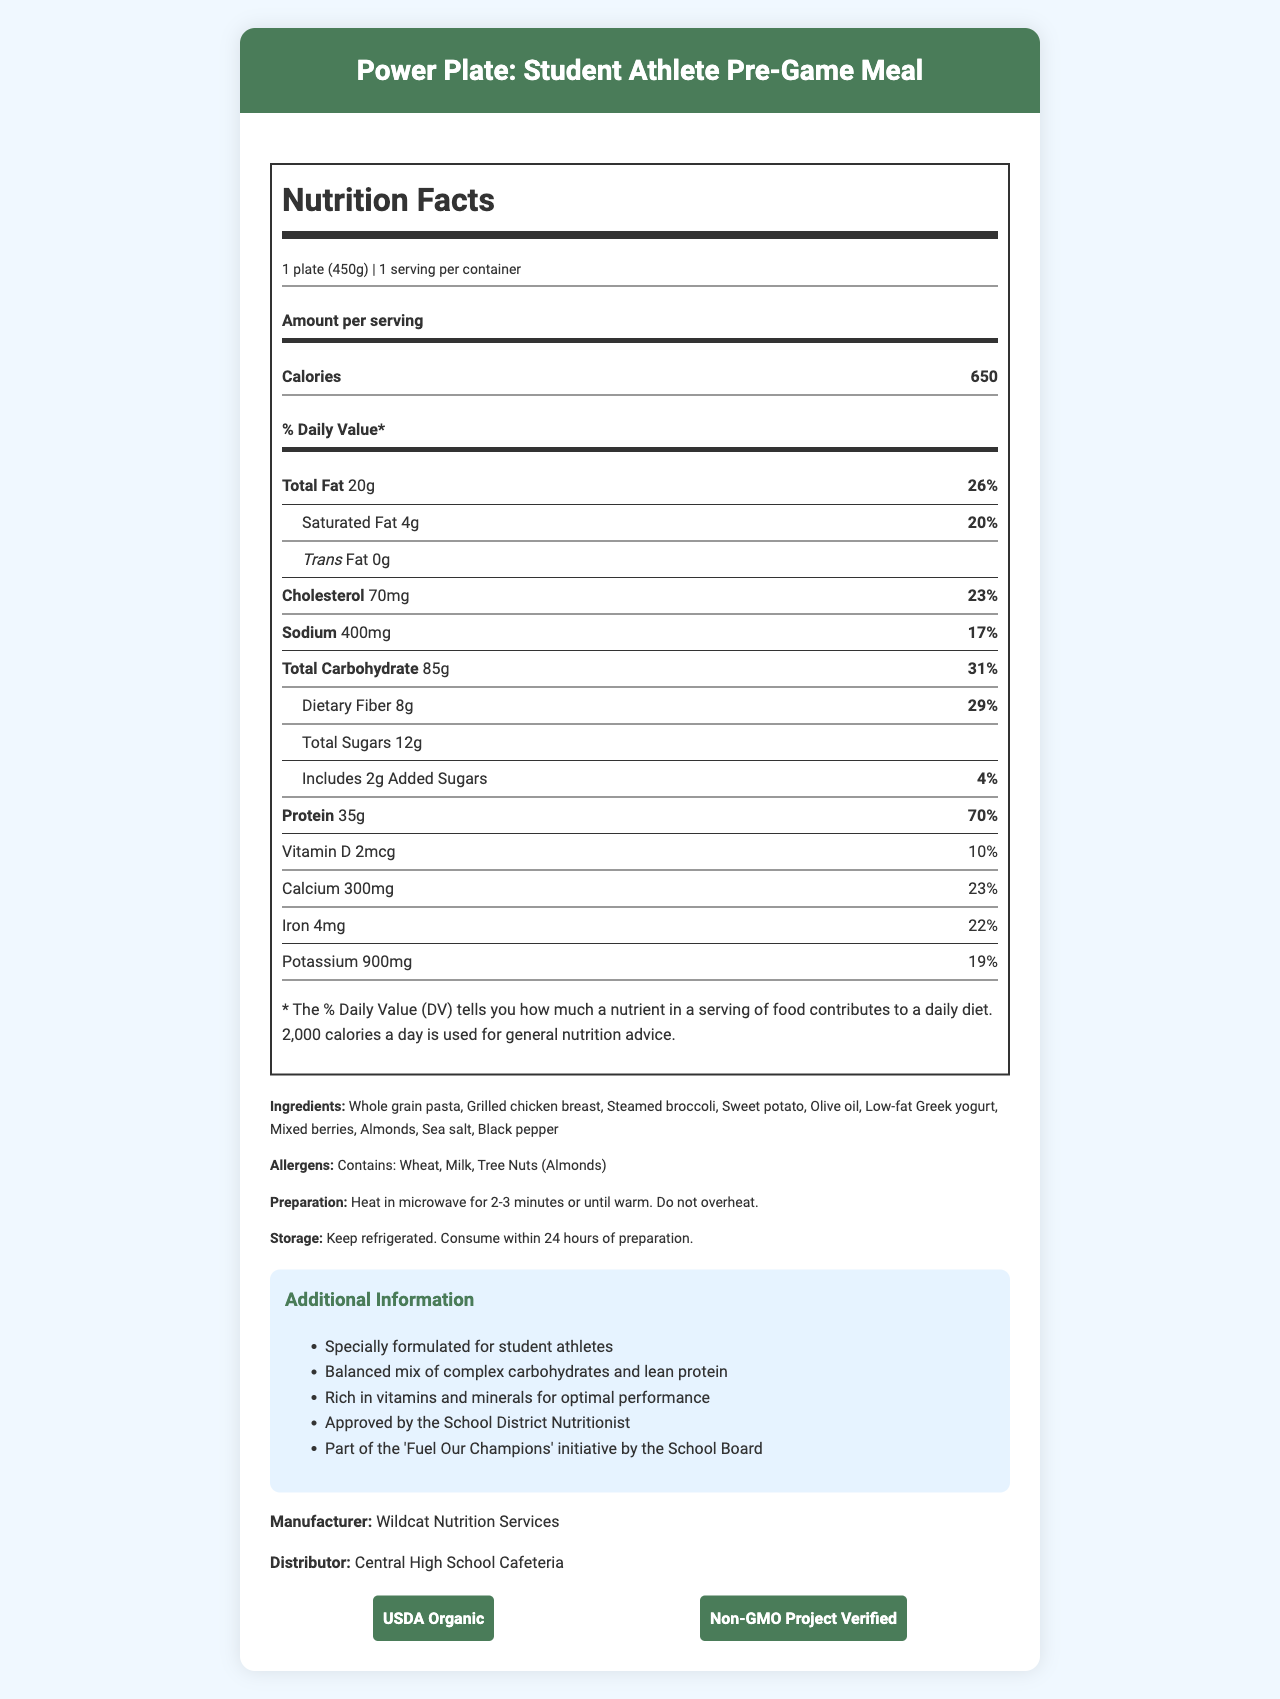what is the serving size of the Power Plate? The serving size is mentioned at the beginning of the Nutrition Facts, "1 plate (450g)".
Answer: 1 plate (450g) how many servings are there per container? The Nutrition Facts state that there is 1 serving per container.
Answer: 1 what is the calorie content per serving? The calorie content per serving is listed under the Nutrition Facts as 650 calories.
Answer: 650 how much protein does the Power Plate contain? The amount of protein is detailed under the protein section in the Nutrition Facts as 35g.
Answer: 35g what is the main ingredient in the Power Plate? The first ingredient listed under Ingredients is "Whole grain pasta".
Answer: Whole grain pasta what percentage of the daily value is the total fat? The total fat is listed as 20g, and its daily value is indicated as 26%.
Answer: 26% how many grams of dietary fiber are present? The amount of dietary fiber is listed under the total carbohydrate section in the Nutrition Facts as 8g.
Answer: 8g what are the allergens mentioned? The allergens are listed as "Contains: Wheat, Milk, Tree Nuts (Almonds)".
Answer: Wheat, Milk, Tree Nuts (Almonds) what certifications does the Power Plate have? A. USDA Organic B. Gluten-Free C. Non-GMO Project Verified D. All of the above The certifications listed at the bottom of the document are USDA Organic and Non-GMO Project Verified.
Answer: A.C how is the Power Plate prepared? A. Boil for 10 minutes B. Microwave for 2-3 minutes C. Bake for 20 minutes D. Consume raw The preparation instructions say to "Heat in microwave for 2-3 minutes or until warm."
Answer: B is the Power Plate part of any school initiative? The document mentions it is part of the "Fuel Our Champions" initiative by the School Board.
Answer: Yes summarize the main idea of the document. The document outlines the nutritional composition and key details about the Power Plate, designed for student athletes and endorsed by the school nutrition program.
Answer: The document provides the Nutrition Facts for the Power Plate: Student Athlete Pre-Game Meal, detailing serving size, calories, macronutrient content, vitamins, minerals, ingredients, allergens, preparation and storage instructions, certifications, and additional information about its formulation and purpose. can you determine who the manufacturer distributes to? The document specifies the distributor as "Central High School Cafeteria" but does not include specifics on who the manufacturer distributes to.
Answer: No 